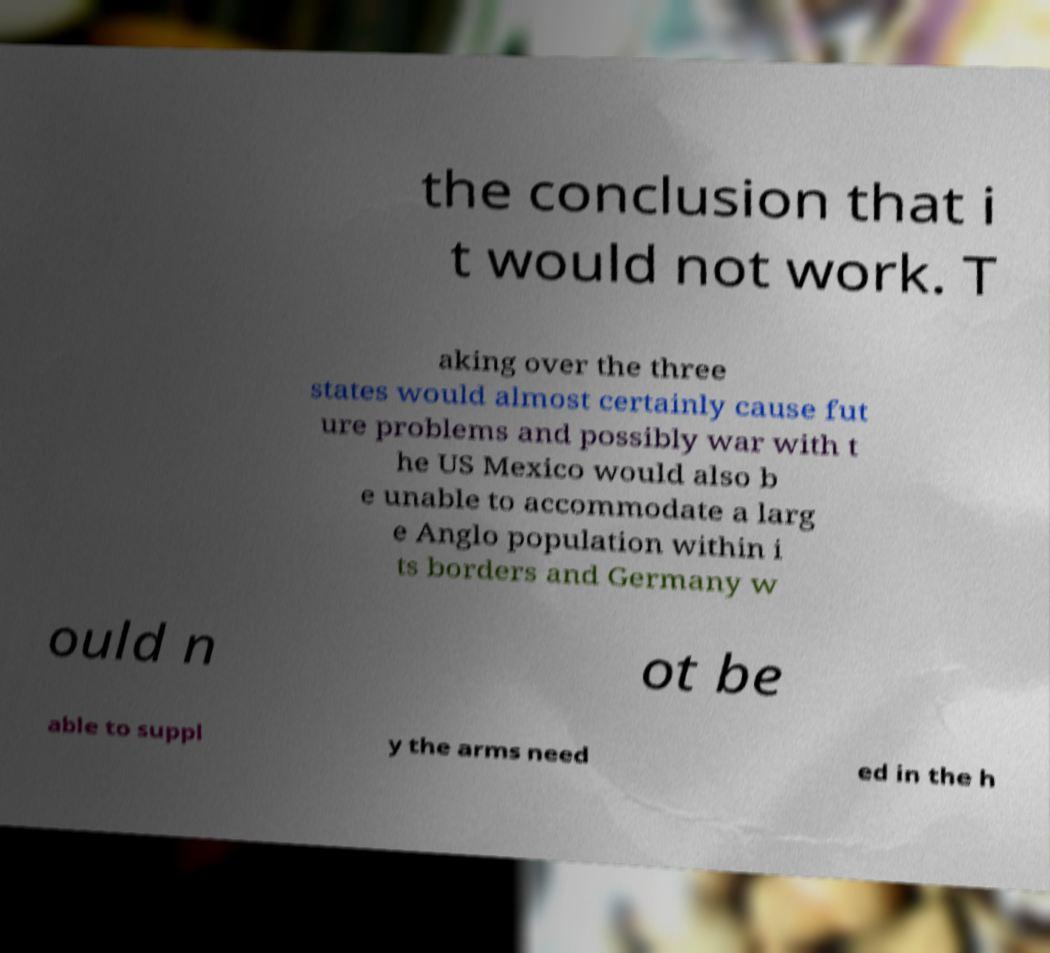There's text embedded in this image that I need extracted. Can you transcribe it verbatim? the conclusion that i t would not work. T aking over the three states would almost certainly cause fut ure problems and possibly war with t he US Mexico would also b e unable to accommodate a larg e Anglo population within i ts borders and Germany w ould n ot be able to suppl y the arms need ed in the h 